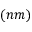<formula> <loc_0><loc_0><loc_500><loc_500>( n m )</formula> 